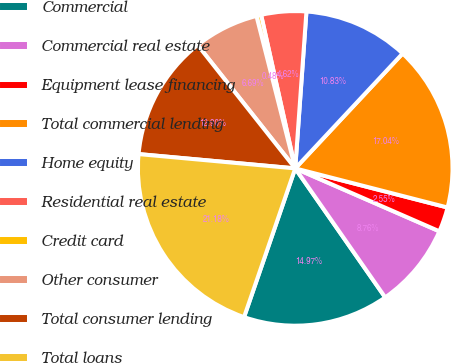<chart> <loc_0><loc_0><loc_500><loc_500><pie_chart><fcel>Commercial<fcel>Commercial real estate<fcel>Equipment lease financing<fcel>Total commercial lending<fcel>Home equity<fcel>Residential real estate<fcel>Credit card<fcel>Other consumer<fcel>Total consumer lending<fcel>Total loans<nl><fcel>14.97%<fcel>8.76%<fcel>2.55%<fcel>17.04%<fcel>10.83%<fcel>4.62%<fcel>0.48%<fcel>6.69%<fcel>12.9%<fcel>21.18%<nl></chart> 